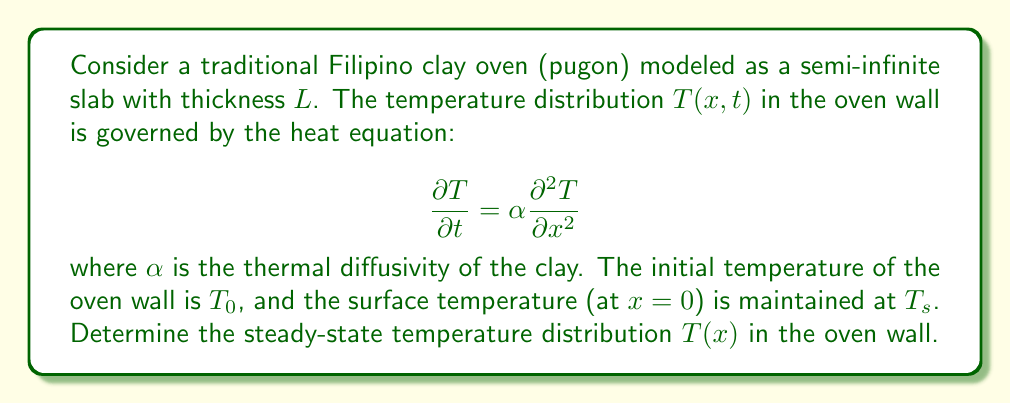What is the answer to this math problem? To solve this problem, we'll follow these steps:

1) For steady-state conditions, the temperature doesn't change with time, so ∂T/∂t = 0. The heat equation reduces to:

   $$0 = \alpha \frac{d^2 T}{dx^2}$$

2) Integrating twice with respect to x:

   $$\frac{dT}{dx} = C_1$$
   $$T(x) = C_1x + C_2$$

   where C₁ and C₂ are constants of integration.

3) Now, we apply the boundary conditions:
   At x = 0, T = Ts
   At x = L, T = T₀

4) Applying these conditions:
   T(0) = Ts = C₂
   T(L) = T₀ = C₁L + C₂

5) From the first condition, C₂ = Ts
   From the second condition: T₀ = C₁L + Ts
   Solving for C₁: C₁ = (T₀ - Ts) / L

6) Substituting these values back into the general solution:

   $$T(x) = \frac{T_0 - T_s}{L}x + T_s$$

This linear equation describes the steady-state temperature distribution in the oven wall.
Answer: $$T(x) = \frac{T_0 - T_s}{L}x + T_s$$ 